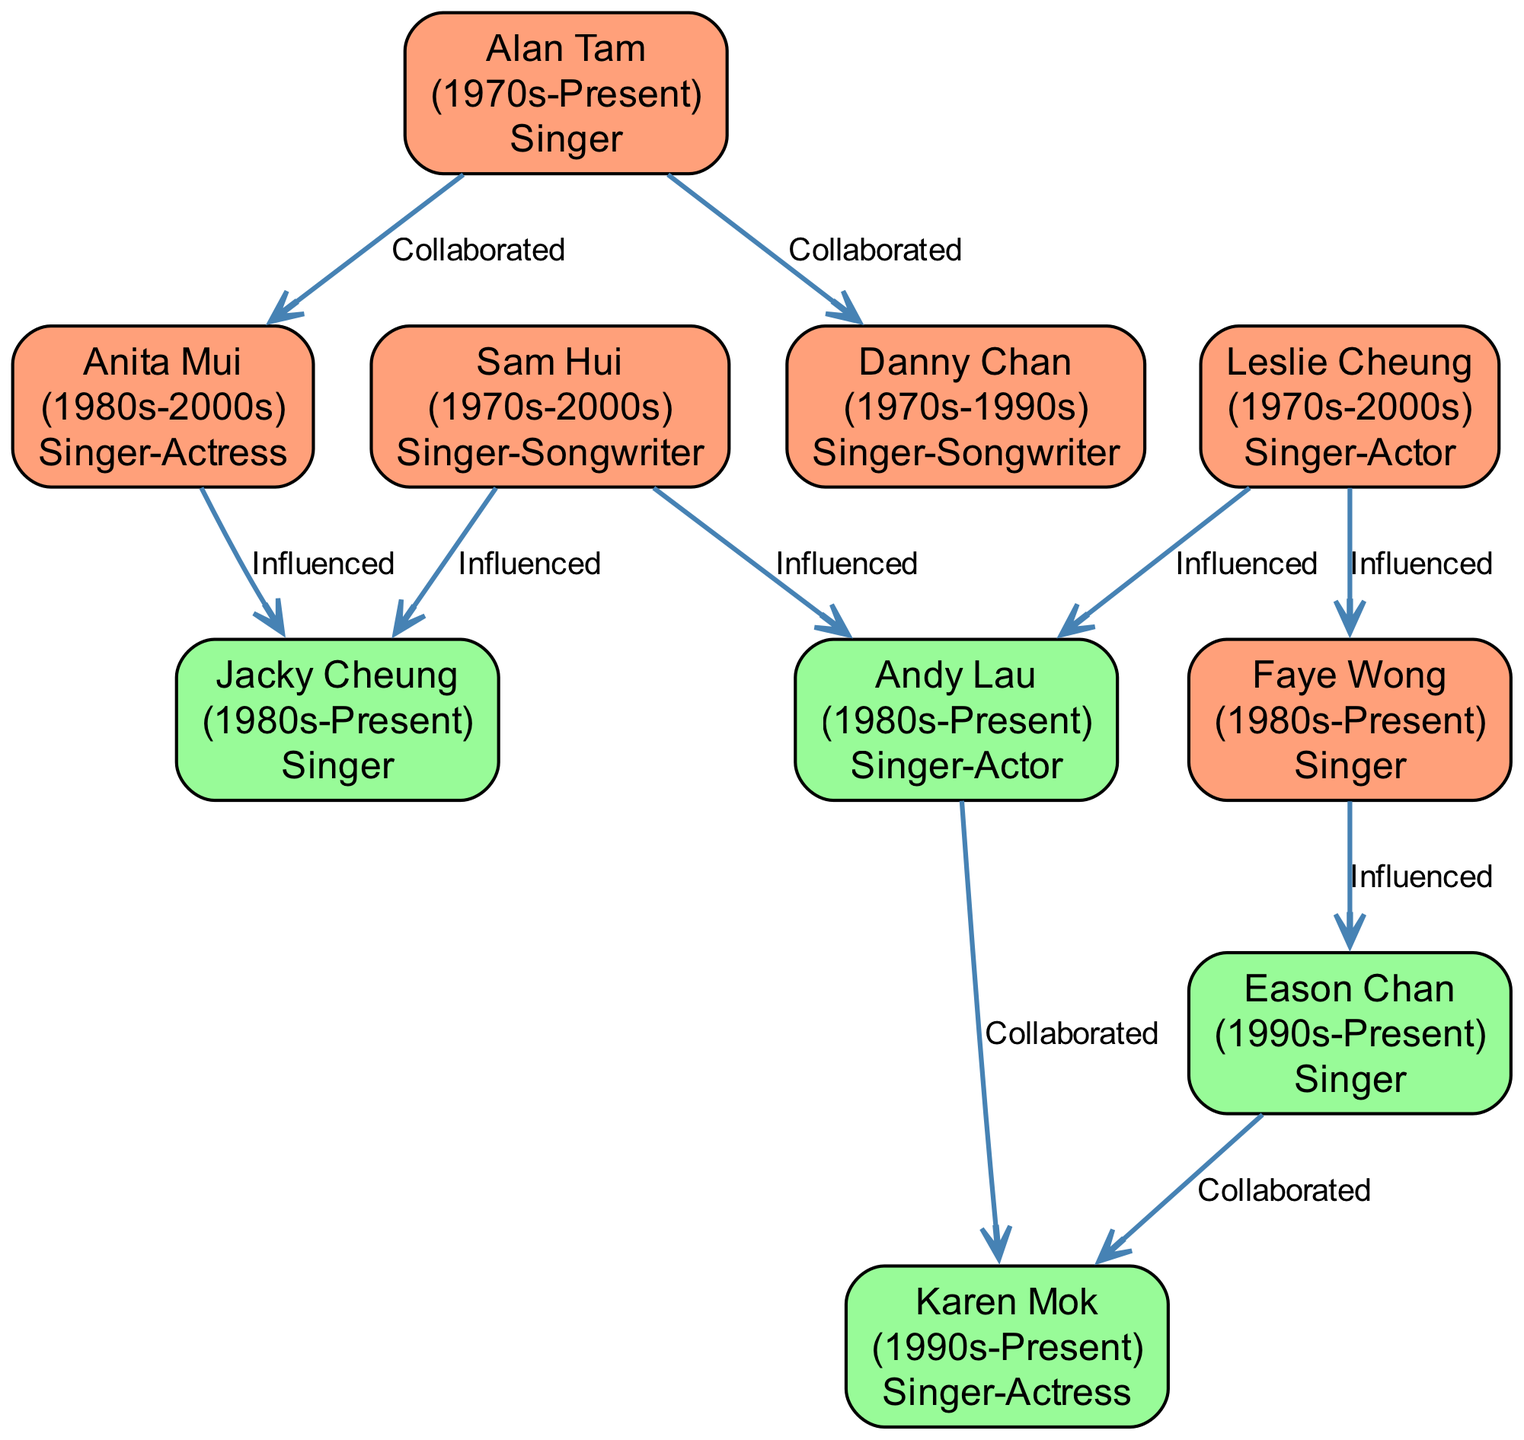What is the total number of musicians represented in the diagram? The diagram includes a list of nodes representing musicians, which totals 10 individuals.
Answer: 10 Who influenced Eason Chan? Based on the links in the diagram, Eason Chan was influenced by Faye Wong.
Answer: Faye Wong Which musician collaborated with Andy Lau? The diagram shows that Andy Lau collaborated with Karen Mok.
Answer: Karen Mok How many musicians are categorized as "Influence"? By examining the nodes, there are 6 musicians categorized as "Influence."
Answer: 6 Who is represented as a "Singer-Actor" and is an influence? The diagram indicates that Leslie Cheung is a "Singer-Actor" and categorized as an influence.
Answer: Leslie Cheung What type of relationship exists between Jacky Cheung and Sam Hui? The diagram shows that Jacky Cheung was influenced by Sam Hui, indicating a one-way influence relationship.
Answer: Influenced Which musician both collaborated with and was influenced by Sam Hui? Analyzing the diagram, it is clear that Andy Lau both collaborated with Sam Hui and was influenced by him.
Answer: Andy Lau How many collaborations are shown in the diagram? By counting the links labeled "Collaborated" in the diagram, there are 5 collaborations displayed.
Answer: 5 What role does Anita Mui fulfill in the diagram? According to the node information, Anita Mui is represented as a "Singer-Actress."
Answer: Singer-Actress 